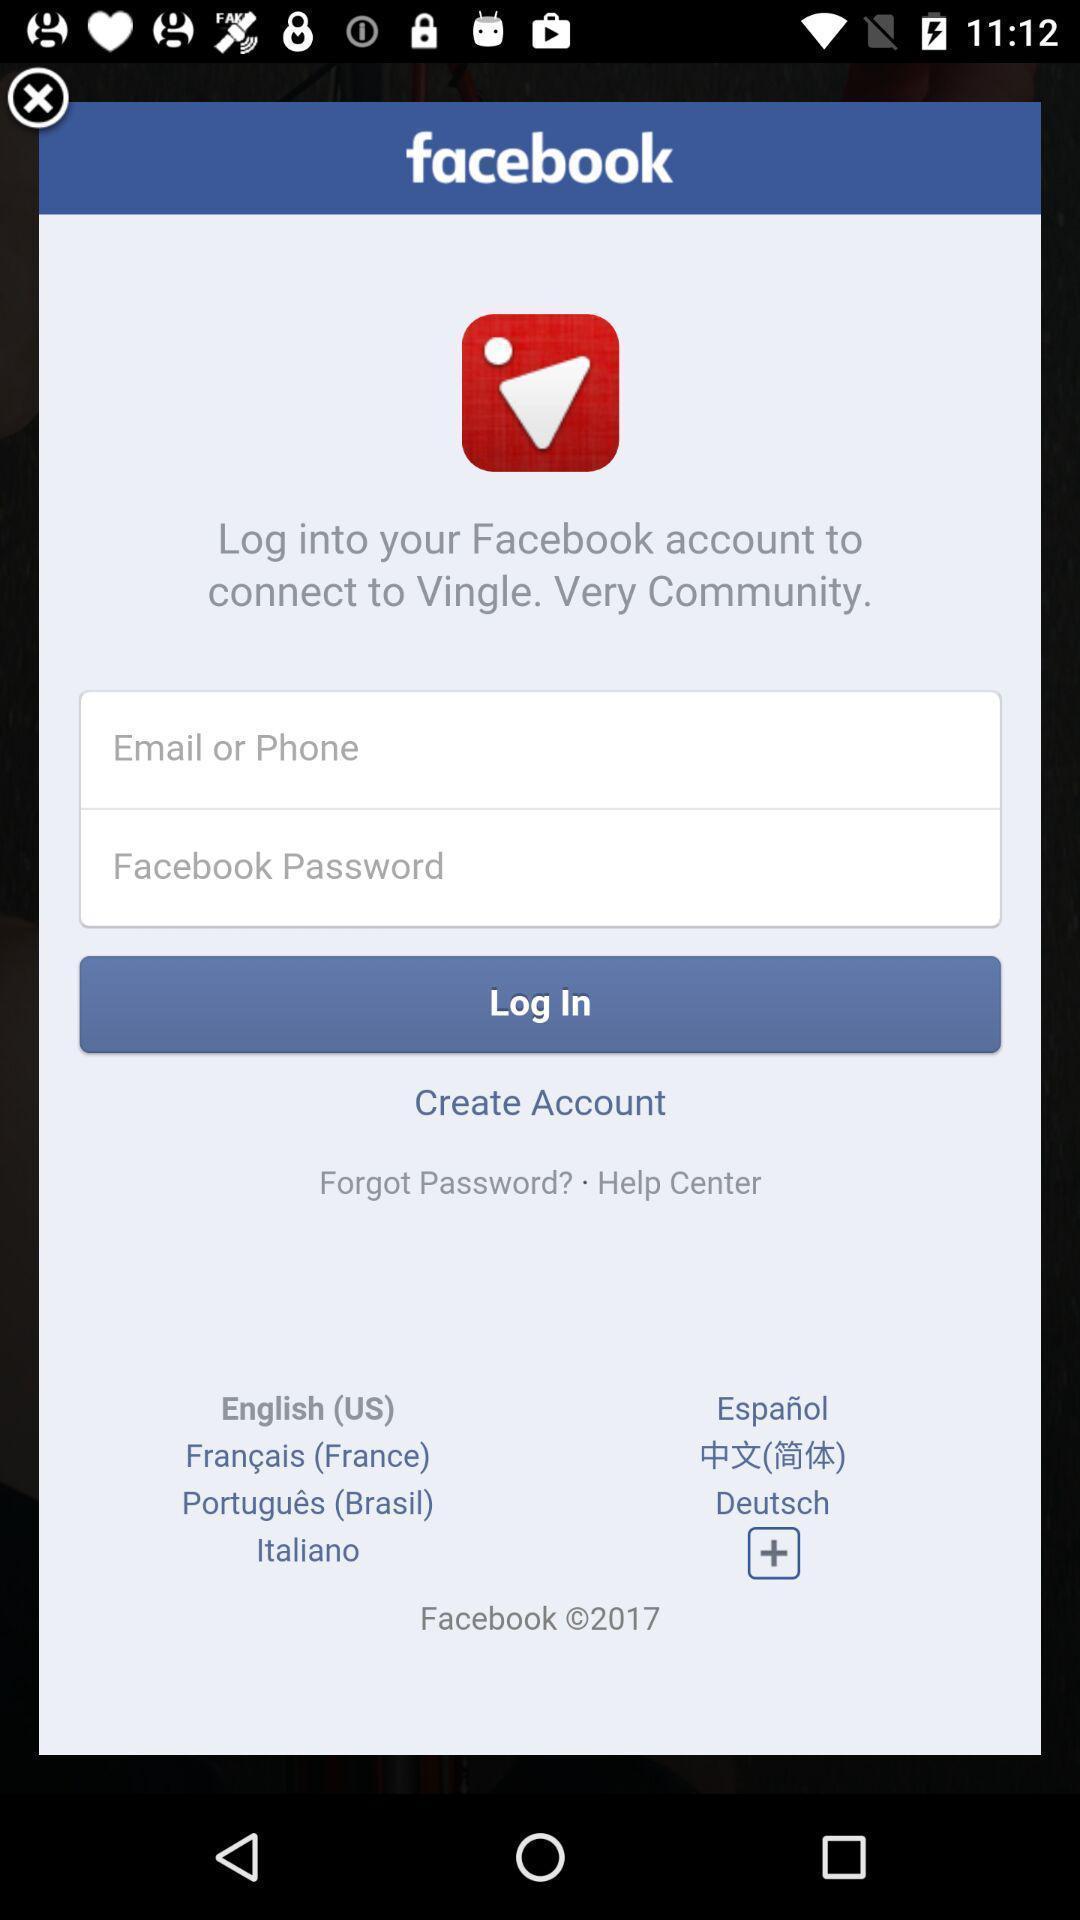Give me a summary of this screen capture. Welcome to the login page. 